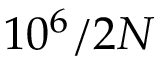<formula> <loc_0><loc_0><loc_500><loc_500>1 0 ^ { 6 } / 2 N</formula> 